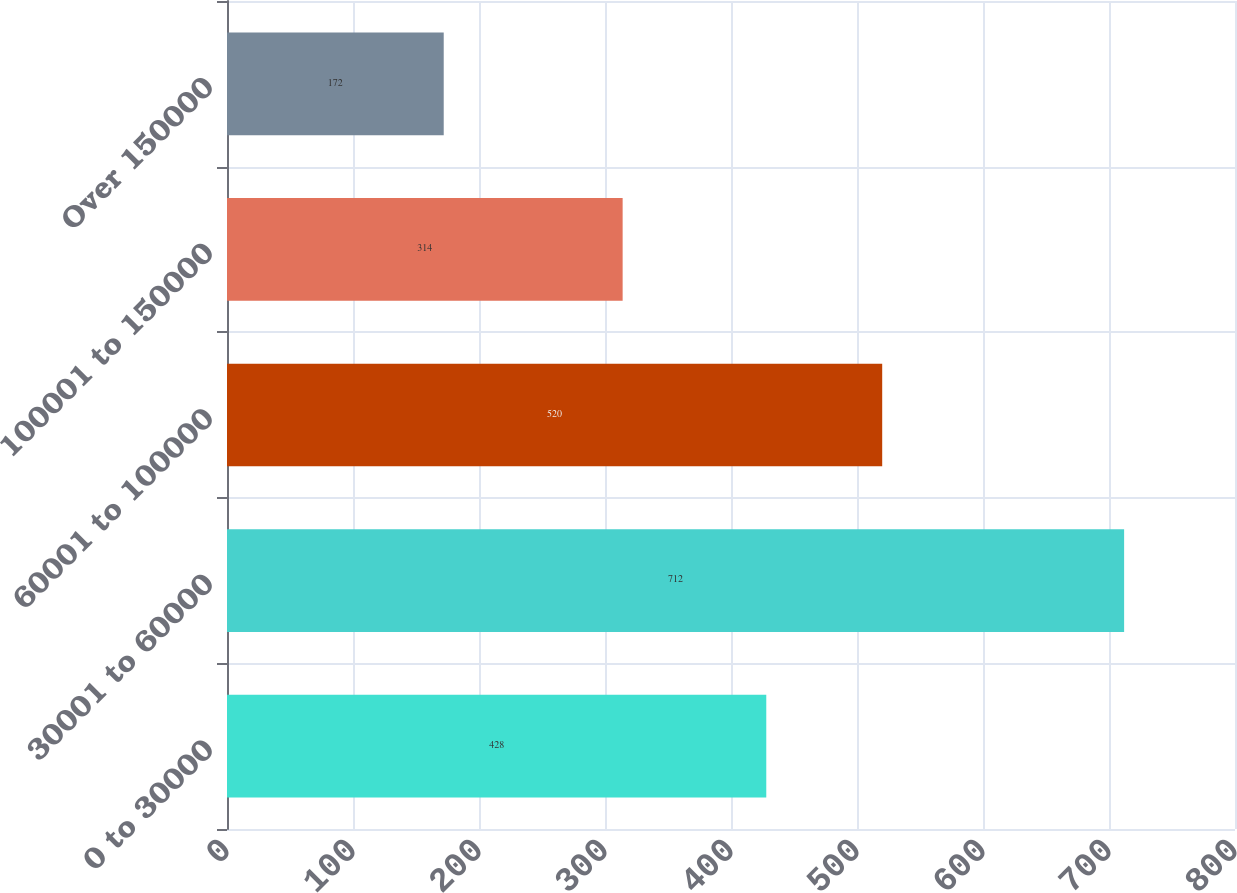<chart> <loc_0><loc_0><loc_500><loc_500><bar_chart><fcel>0 to 30000<fcel>30001 to 60000<fcel>60001 to 100000<fcel>100001 to 150000<fcel>Over 150000<nl><fcel>428<fcel>712<fcel>520<fcel>314<fcel>172<nl></chart> 